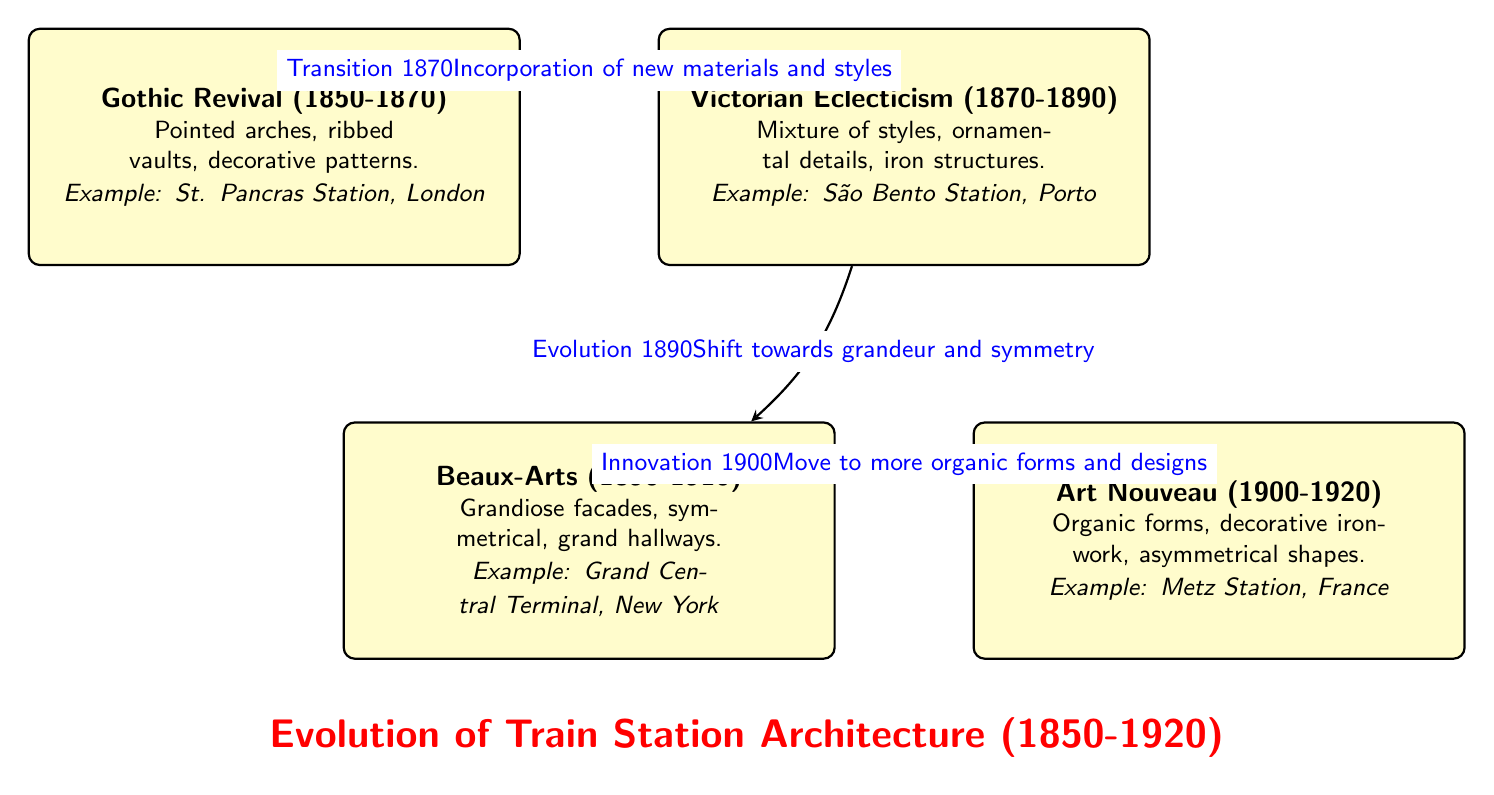What are the architectural styles represented in the diagram? The diagram has four nodes, each representing a distinct architectural style: Gothic Revival, Victorian Eclecticism, Beaux-Arts, and Art Nouveau.
Answer: Gothic Revival, Victorian Eclecticism, Beaux-Arts, Art Nouveau What is the time span of the Gothic Revival architecture? According to the diagram, the Gothic Revival architecture is represented with a time span from 1850 to 1870.
Answer: 1850-1870 What transition occurred in 1870? The diagram specifies that in 1870, there was a transition that involved the incorporation of new materials and styles from Gothic Revival to Victorian Eclecticism.
Answer: Incorporation of new materials and styles Which architectural style follows Beaux-Arts in the diagram? The diagram indicates that Art Nouveau follows Beaux-Arts in the chronological evolution of train station architecture.
Answer: Art Nouveau What example of a train station is associated with the Beaux-Arts style? According to the diagram, Grand Central Terminal in New York is the example given for the Beaux-Arts architectural style.
Answer: Grand Central Terminal, New York What kind of forms characterizes the Art Nouveau style? The diagram describes the Art Nouveau style as characterized by organic forms and decorative ironwork.
Answer: Organic forms, decorative ironwork How many edges are present in the diagram? The diagram shows a total of three edges connecting the four architectural styles, depicting the transitions and evolution between them.
Answer: 3 What was the shift towards grandeur and symmetry associated with? The diagram notes that the shift towards grandeur and symmetry is associated with the evolution from Victorian Eclecticism to Beaux-Arts in 1890.
Answer: Evolution from Victorian Eclecticism to Beaux-Arts Which architectural style is noted for its grandiose facades? From the information in the diagram, the Beaux-Arts architectural style is noted for its grandiose facades.
Answer: Beaux-Arts 